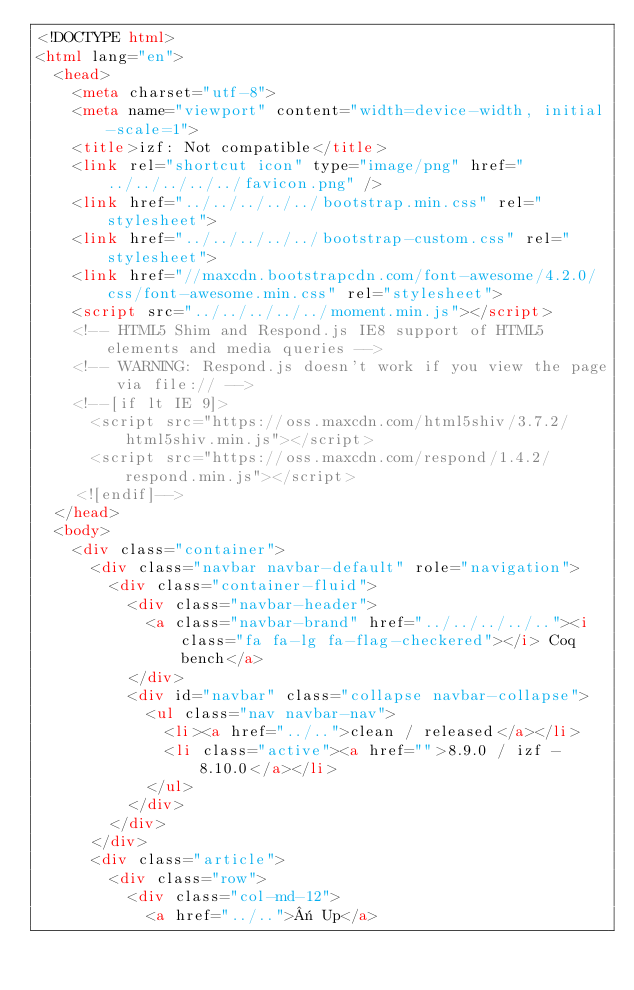Convert code to text. <code><loc_0><loc_0><loc_500><loc_500><_HTML_><!DOCTYPE html>
<html lang="en">
  <head>
    <meta charset="utf-8">
    <meta name="viewport" content="width=device-width, initial-scale=1">
    <title>izf: Not compatible</title>
    <link rel="shortcut icon" type="image/png" href="../../../../../favicon.png" />
    <link href="../../../../../bootstrap.min.css" rel="stylesheet">
    <link href="../../../../../bootstrap-custom.css" rel="stylesheet">
    <link href="//maxcdn.bootstrapcdn.com/font-awesome/4.2.0/css/font-awesome.min.css" rel="stylesheet">
    <script src="../../../../../moment.min.js"></script>
    <!-- HTML5 Shim and Respond.js IE8 support of HTML5 elements and media queries -->
    <!-- WARNING: Respond.js doesn't work if you view the page via file:// -->
    <!--[if lt IE 9]>
      <script src="https://oss.maxcdn.com/html5shiv/3.7.2/html5shiv.min.js"></script>
      <script src="https://oss.maxcdn.com/respond/1.4.2/respond.min.js"></script>
    <![endif]-->
  </head>
  <body>
    <div class="container">
      <div class="navbar navbar-default" role="navigation">
        <div class="container-fluid">
          <div class="navbar-header">
            <a class="navbar-brand" href="../../../../.."><i class="fa fa-lg fa-flag-checkered"></i> Coq bench</a>
          </div>
          <div id="navbar" class="collapse navbar-collapse">
            <ul class="nav navbar-nav">
              <li><a href="../..">clean / released</a></li>
              <li class="active"><a href="">8.9.0 / izf - 8.10.0</a></li>
            </ul>
          </div>
        </div>
      </div>
      <div class="article">
        <div class="row">
          <div class="col-md-12">
            <a href="../..">« Up</a></code> 